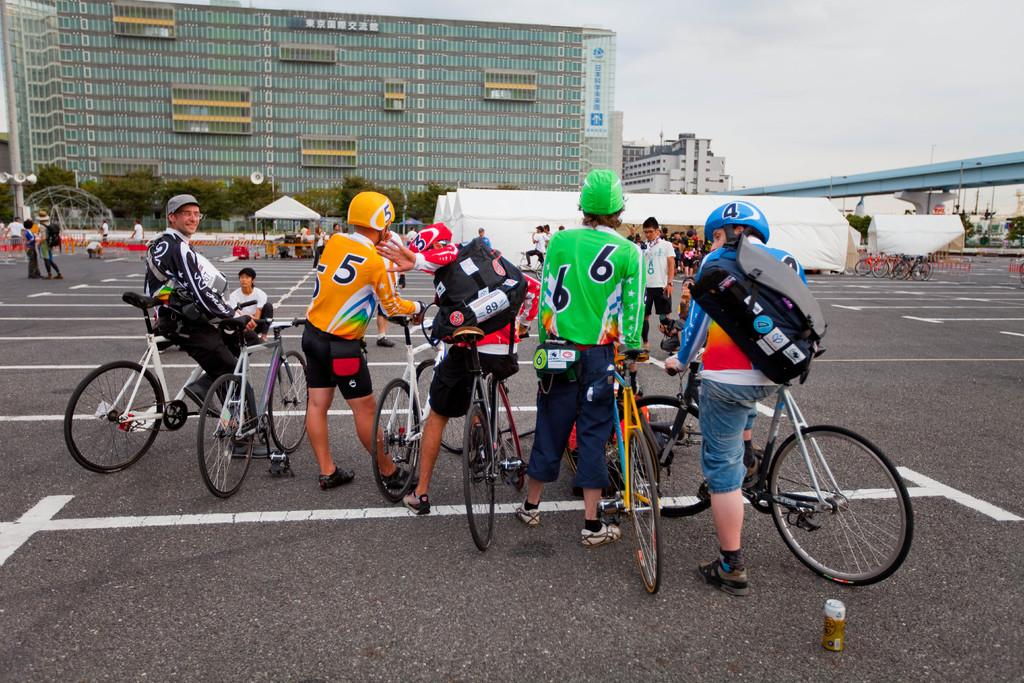What are the people in the image doing? The people in the image are standing and holding bicycles. What can be seen in the background of the image? There are buildings visible in the image. What type of temporary shelter is present in the image? There are tents in the image. How many people are visible in the image? There are additional people in the image besides those holding bicycles. What type of cakes are being served from the truck in the image? There is no truck or cakes present in the image. What level of difficulty is the obstacle course in the image? There is no obstacle course present in the image. 